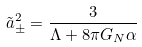Convert formula to latex. <formula><loc_0><loc_0><loc_500><loc_500>\tilde { a } _ { \pm } ^ { 2 } = \frac { 3 } { \Lambda + 8 \pi G _ { N } \alpha }</formula> 